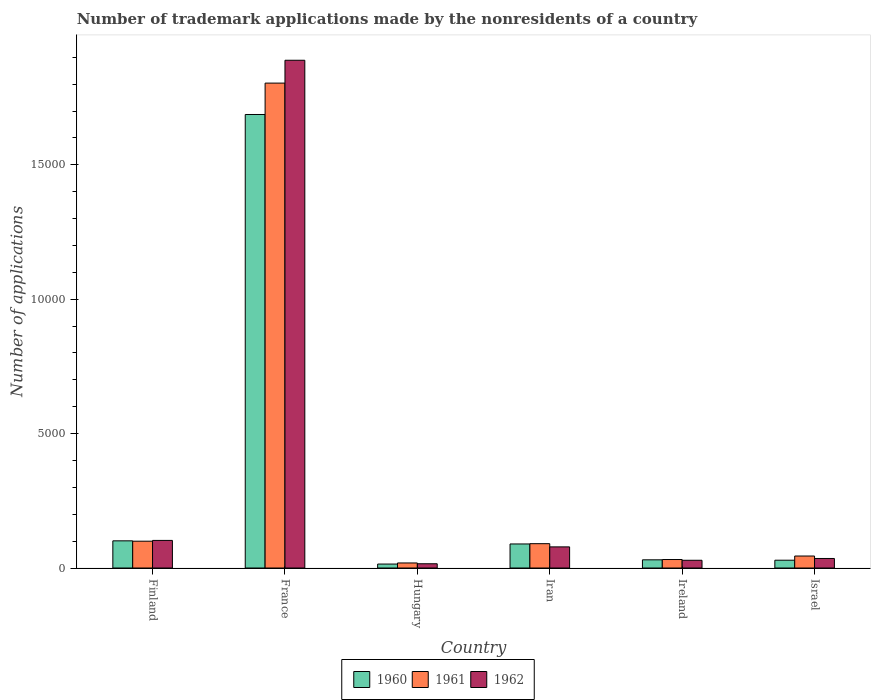How many different coloured bars are there?
Your answer should be very brief. 3. How many groups of bars are there?
Make the answer very short. 6. Are the number of bars per tick equal to the number of legend labels?
Your response must be concise. Yes. How many bars are there on the 4th tick from the left?
Give a very brief answer. 3. What is the number of trademark applications made by the nonresidents in 1961 in Ireland?
Your answer should be compact. 316. Across all countries, what is the maximum number of trademark applications made by the nonresidents in 1960?
Ensure brevity in your answer.  1.69e+04. Across all countries, what is the minimum number of trademark applications made by the nonresidents in 1962?
Offer a very short reply. 158. In which country was the number of trademark applications made by the nonresidents in 1962 minimum?
Your answer should be compact. Hungary. What is the total number of trademark applications made by the nonresidents in 1961 in the graph?
Ensure brevity in your answer.  2.09e+04. What is the difference between the number of trademark applications made by the nonresidents in 1961 in France and that in Iran?
Offer a terse response. 1.71e+04. What is the difference between the number of trademark applications made by the nonresidents in 1962 in Ireland and the number of trademark applications made by the nonresidents in 1960 in Iran?
Give a very brief answer. -607. What is the average number of trademark applications made by the nonresidents in 1960 per country?
Your answer should be compact. 3253.67. In how many countries, is the number of trademark applications made by the nonresidents in 1961 greater than 2000?
Provide a short and direct response. 1. What is the ratio of the number of trademark applications made by the nonresidents in 1961 in Iran to that in Israel?
Offer a very short reply. 2.03. Is the number of trademark applications made by the nonresidents in 1962 in Finland less than that in Iran?
Offer a terse response. No. What is the difference between the highest and the second highest number of trademark applications made by the nonresidents in 1960?
Your answer should be very brief. 1.59e+04. What is the difference between the highest and the lowest number of trademark applications made by the nonresidents in 1962?
Provide a short and direct response. 1.87e+04. What does the 3rd bar from the left in Finland represents?
Your response must be concise. 1962. What does the 3rd bar from the right in Finland represents?
Offer a very short reply. 1960. Are all the bars in the graph horizontal?
Provide a short and direct response. No. How many countries are there in the graph?
Your answer should be compact. 6. Does the graph contain any zero values?
Provide a short and direct response. No. Does the graph contain grids?
Provide a succinct answer. No. Where does the legend appear in the graph?
Your answer should be very brief. Bottom center. How many legend labels are there?
Provide a succinct answer. 3. How are the legend labels stacked?
Your response must be concise. Horizontal. What is the title of the graph?
Keep it short and to the point. Number of trademark applications made by the nonresidents of a country. Does "1969" appear as one of the legend labels in the graph?
Ensure brevity in your answer.  No. What is the label or title of the X-axis?
Provide a succinct answer. Country. What is the label or title of the Y-axis?
Ensure brevity in your answer.  Number of applications. What is the Number of applications of 1960 in Finland?
Give a very brief answer. 1011. What is the Number of applications of 1961 in Finland?
Provide a short and direct response. 998. What is the Number of applications of 1962 in Finland?
Offer a very short reply. 1027. What is the Number of applications in 1960 in France?
Your answer should be compact. 1.69e+04. What is the Number of applications of 1961 in France?
Provide a succinct answer. 1.80e+04. What is the Number of applications in 1962 in France?
Keep it short and to the point. 1.89e+04. What is the Number of applications in 1960 in Hungary?
Offer a very short reply. 147. What is the Number of applications of 1961 in Hungary?
Your answer should be very brief. 188. What is the Number of applications in 1962 in Hungary?
Offer a terse response. 158. What is the Number of applications of 1960 in Iran?
Give a very brief answer. 895. What is the Number of applications of 1961 in Iran?
Make the answer very short. 905. What is the Number of applications in 1962 in Iran?
Provide a succinct answer. 786. What is the Number of applications in 1960 in Ireland?
Your answer should be very brief. 305. What is the Number of applications in 1961 in Ireland?
Your answer should be very brief. 316. What is the Number of applications in 1962 in Ireland?
Offer a terse response. 288. What is the Number of applications in 1960 in Israel?
Make the answer very short. 290. What is the Number of applications in 1961 in Israel?
Provide a short and direct response. 446. What is the Number of applications of 1962 in Israel?
Give a very brief answer. 355. Across all countries, what is the maximum Number of applications of 1960?
Your answer should be compact. 1.69e+04. Across all countries, what is the maximum Number of applications of 1961?
Your answer should be compact. 1.80e+04. Across all countries, what is the maximum Number of applications of 1962?
Give a very brief answer. 1.89e+04. Across all countries, what is the minimum Number of applications of 1960?
Ensure brevity in your answer.  147. Across all countries, what is the minimum Number of applications in 1961?
Your response must be concise. 188. Across all countries, what is the minimum Number of applications in 1962?
Provide a succinct answer. 158. What is the total Number of applications in 1960 in the graph?
Make the answer very short. 1.95e+04. What is the total Number of applications of 1961 in the graph?
Provide a short and direct response. 2.09e+04. What is the total Number of applications of 1962 in the graph?
Ensure brevity in your answer.  2.15e+04. What is the difference between the Number of applications of 1960 in Finland and that in France?
Ensure brevity in your answer.  -1.59e+04. What is the difference between the Number of applications of 1961 in Finland and that in France?
Give a very brief answer. -1.70e+04. What is the difference between the Number of applications in 1962 in Finland and that in France?
Make the answer very short. -1.79e+04. What is the difference between the Number of applications in 1960 in Finland and that in Hungary?
Your answer should be compact. 864. What is the difference between the Number of applications of 1961 in Finland and that in Hungary?
Give a very brief answer. 810. What is the difference between the Number of applications of 1962 in Finland and that in Hungary?
Keep it short and to the point. 869. What is the difference between the Number of applications of 1960 in Finland and that in Iran?
Keep it short and to the point. 116. What is the difference between the Number of applications of 1961 in Finland and that in Iran?
Provide a short and direct response. 93. What is the difference between the Number of applications of 1962 in Finland and that in Iran?
Provide a succinct answer. 241. What is the difference between the Number of applications of 1960 in Finland and that in Ireland?
Give a very brief answer. 706. What is the difference between the Number of applications in 1961 in Finland and that in Ireland?
Keep it short and to the point. 682. What is the difference between the Number of applications in 1962 in Finland and that in Ireland?
Provide a short and direct response. 739. What is the difference between the Number of applications of 1960 in Finland and that in Israel?
Your answer should be compact. 721. What is the difference between the Number of applications of 1961 in Finland and that in Israel?
Provide a short and direct response. 552. What is the difference between the Number of applications in 1962 in Finland and that in Israel?
Give a very brief answer. 672. What is the difference between the Number of applications in 1960 in France and that in Hungary?
Your answer should be very brief. 1.67e+04. What is the difference between the Number of applications in 1961 in France and that in Hungary?
Your response must be concise. 1.79e+04. What is the difference between the Number of applications in 1962 in France and that in Hungary?
Make the answer very short. 1.87e+04. What is the difference between the Number of applications of 1960 in France and that in Iran?
Offer a terse response. 1.60e+04. What is the difference between the Number of applications in 1961 in France and that in Iran?
Give a very brief answer. 1.71e+04. What is the difference between the Number of applications in 1962 in France and that in Iran?
Give a very brief answer. 1.81e+04. What is the difference between the Number of applications in 1960 in France and that in Ireland?
Your answer should be compact. 1.66e+04. What is the difference between the Number of applications in 1961 in France and that in Ireland?
Ensure brevity in your answer.  1.77e+04. What is the difference between the Number of applications in 1962 in France and that in Ireland?
Your answer should be compact. 1.86e+04. What is the difference between the Number of applications in 1960 in France and that in Israel?
Offer a very short reply. 1.66e+04. What is the difference between the Number of applications in 1961 in France and that in Israel?
Your answer should be compact. 1.76e+04. What is the difference between the Number of applications of 1962 in France and that in Israel?
Give a very brief answer. 1.85e+04. What is the difference between the Number of applications in 1960 in Hungary and that in Iran?
Provide a succinct answer. -748. What is the difference between the Number of applications of 1961 in Hungary and that in Iran?
Your response must be concise. -717. What is the difference between the Number of applications in 1962 in Hungary and that in Iran?
Offer a terse response. -628. What is the difference between the Number of applications of 1960 in Hungary and that in Ireland?
Your answer should be compact. -158. What is the difference between the Number of applications in 1961 in Hungary and that in Ireland?
Make the answer very short. -128. What is the difference between the Number of applications in 1962 in Hungary and that in Ireland?
Provide a succinct answer. -130. What is the difference between the Number of applications of 1960 in Hungary and that in Israel?
Your answer should be very brief. -143. What is the difference between the Number of applications in 1961 in Hungary and that in Israel?
Make the answer very short. -258. What is the difference between the Number of applications in 1962 in Hungary and that in Israel?
Provide a succinct answer. -197. What is the difference between the Number of applications of 1960 in Iran and that in Ireland?
Give a very brief answer. 590. What is the difference between the Number of applications in 1961 in Iran and that in Ireland?
Offer a very short reply. 589. What is the difference between the Number of applications in 1962 in Iran and that in Ireland?
Provide a succinct answer. 498. What is the difference between the Number of applications in 1960 in Iran and that in Israel?
Make the answer very short. 605. What is the difference between the Number of applications in 1961 in Iran and that in Israel?
Ensure brevity in your answer.  459. What is the difference between the Number of applications of 1962 in Iran and that in Israel?
Make the answer very short. 431. What is the difference between the Number of applications of 1961 in Ireland and that in Israel?
Your answer should be very brief. -130. What is the difference between the Number of applications of 1962 in Ireland and that in Israel?
Ensure brevity in your answer.  -67. What is the difference between the Number of applications of 1960 in Finland and the Number of applications of 1961 in France?
Your answer should be very brief. -1.70e+04. What is the difference between the Number of applications of 1960 in Finland and the Number of applications of 1962 in France?
Provide a succinct answer. -1.79e+04. What is the difference between the Number of applications of 1961 in Finland and the Number of applications of 1962 in France?
Make the answer very short. -1.79e+04. What is the difference between the Number of applications of 1960 in Finland and the Number of applications of 1961 in Hungary?
Your response must be concise. 823. What is the difference between the Number of applications in 1960 in Finland and the Number of applications in 1962 in Hungary?
Keep it short and to the point. 853. What is the difference between the Number of applications of 1961 in Finland and the Number of applications of 1962 in Hungary?
Provide a short and direct response. 840. What is the difference between the Number of applications of 1960 in Finland and the Number of applications of 1961 in Iran?
Your answer should be very brief. 106. What is the difference between the Number of applications of 1960 in Finland and the Number of applications of 1962 in Iran?
Your answer should be compact. 225. What is the difference between the Number of applications in 1961 in Finland and the Number of applications in 1962 in Iran?
Provide a succinct answer. 212. What is the difference between the Number of applications of 1960 in Finland and the Number of applications of 1961 in Ireland?
Your answer should be compact. 695. What is the difference between the Number of applications of 1960 in Finland and the Number of applications of 1962 in Ireland?
Offer a terse response. 723. What is the difference between the Number of applications of 1961 in Finland and the Number of applications of 1962 in Ireland?
Ensure brevity in your answer.  710. What is the difference between the Number of applications of 1960 in Finland and the Number of applications of 1961 in Israel?
Your response must be concise. 565. What is the difference between the Number of applications of 1960 in Finland and the Number of applications of 1962 in Israel?
Your response must be concise. 656. What is the difference between the Number of applications in 1961 in Finland and the Number of applications in 1962 in Israel?
Keep it short and to the point. 643. What is the difference between the Number of applications of 1960 in France and the Number of applications of 1961 in Hungary?
Keep it short and to the point. 1.67e+04. What is the difference between the Number of applications in 1960 in France and the Number of applications in 1962 in Hungary?
Provide a succinct answer. 1.67e+04. What is the difference between the Number of applications of 1961 in France and the Number of applications of 1962 in Hungary?
Your answer should be compact. 1.79e+04. What is the difference between the Number of applications in 1960 in France and the Number of applications in 1961 in Iran?
Ensure brevity in your answer.  1.60e+04. What is the difference between the Number of applications of 1960 in France and the Number of applications of 1962 in Iran?
Your response must be concise. 1.61e+04. What is the difference between the Number of applications in 1961 in France and the Number of applications in 1962 in Iran?
Your answer should be compact. 1.73e+04. What is the difference between the Number of applications in 1960 in France and the Number of applications in 1961 in Ireland?
Give a very brief answer. 1.66e+04. What is the difference between the Number of applications in 1960 in France and the Number of applications in 1962 in Ireland?
Keep it short and to the point. 1.66e+04. What is the difference between the Number of applications of 1961 in France and the Number of applications of 1962 in Ireland?
Ensure brevity in your answer.  1.78e+04. What is the difference between the Number of applications of 1960 in France and the Number of applications of 1961 in Israel?
Your answer should be very brief. 1.64e+04. What is the difference between the Number of applications of 1960 in France and the Number of applications of 1962 in Israel?
Your response must be concise. 1.65e+04. What is the difference between the Number of applications in 1961 in France and the Number of applications in 1962 in Israel?
Offer a terse response. 1.77e+04. What is the difference between the Number of applications of 1960 in Hungary and the Number of applications of 1961 in Iran?
Ensure brevity in your answer.  -758. What is the difference between the Number of applications in 1960 in Hungary and the Number of applications in 1962 in Iran?
Offer a terse response. -639. What is the difference between the Number of applications in 1961 in Hungary and the Number of applications in 1962 in Iran?
Ensure brevity in your answer.  -598. What is the difference between the Number of applications in 1960 in Hungary and the Number of applications in 1961 in Ireland?
Your answer should be compact. -169. What is the difference between the Number of applications of 1960 in Hungary and the Number of applications of 1962 in Ireland?
Offer a terse response. -141. What is the difference between the Number of applications in 1961 in Hungary and the Number of applications in 1962 in Ireland?
Provide a short and direct response. -100. What is the difference between the Number of applications of 1960 in Hungary and the Number of applications of 1961 in Israel?
Give a very brief answer. -299. What is the difference between the Number of applications in 1960 in Hungary and the Number of applications in 1962 in Israel?
Offer a terse response. -208. What is the difference between the Number of applications in 1961 in Hungary and the Number of applications in 1962 in Israel?
Provide a succinct answer. -167. What is the difference between the Number of applications of 1960 in Iran and the Number of applications of 1961 in Ireland?
Provide a short and direct response. 579. What is the difference between the Number of applications in 1960 in Iran and the Number of applications in 1962 in Ireland?
Your answer should be compact. 607. What is the difference between the Number of applications in 1961 in Iran and the Number of applications in 1962 in Ireland?
Your answer should be compact. 617. What is the difference between the Number of applications in 1960 in Iran and the Number of applications in 1961 in Israel?
Your answer should be very brief. 449. What is the difference between the Number of applications of 1960 in Iran and the Number of applications of 1962 in Israel?
Your answer should be compact. 540. What is the difference between the Number of applications in 1961 in Iran and the Number of applications in 1962 in Israel?
Provide a succinct answer. 550. What is the difference between the Number of applications of 1960 in Ireland and the Number of applications of 1961 in Israel?
Offer a terse response. -141. What is the difference between the Number of applications of 1961 in Ireland and the Number of applications of 1962 in Israel?
Give a very brief answer. -39. What is the average Number of applications of 1960 per country?
Offer a terse response. 3253.67. What is the average Number of applications in 1961 per country?
Provide a short and direct response. 3482.5. What is the average Number of applications of 1962 per country?
Keep it short and to the point. 3584.33. What is the difference between the Number of applications in 1960 and Number of applications in 1962 in Finland?
Provide a short and direct response. -16. What is the difference between the Number of applications of 1961 and Number of applications of 1962 in Finland?
Provide a short and direct response. -29. What is the difference between the Number of applications of 1960 and Number of applications of 1961 in France?
Your response must be concise. -1168. What is the difference between the Number of applications of 1960 and Number of applications of 1962 in France?
Provide a succinct answer. -2018. What is the difference between the Number of applications in 1961 and Number of applications in 1962 in France?
Provide a short and direct response. -850. What is the difference between the Number of applications of 1960 and Number of applications of 1961 in Hungary?
Your answer should be compact. -41. What is the difference between the Number of applications of 1960 and Number of applications of 1962 in Iran?
Provide a succinct answer. 109. What is the difference between the Number of applications of 1961 and Number of applications of 1962 in Iran?
Make the answer very short. 119. What is the difference between the Number of applications of 1960 and Number of applications of 1962 in Ireland?
Your answer should be very brief. 17. What is the difference between the Number of applications of 1960 and Number of applications of 1961 in Israel?
Offer a very short reply. -156. What is the difference between the Number of applications in 1960 and Number of applications in 1962 in Israel?
Your answer should be compact. -65. What is the difference between the Number of applications of 1961 and Number of applications of 1962 in Israel?
Make the answer very short. 91. What is the ratio of the Number of applications in 1960 in Finland to that in France?
Give a very brief answer. 0.06. What is the ratio of the Number of applications in 1961 in Finland to that in France?
Offer a very short reply. 0.06. What is the ratio of the Number of applications of 1962 in Finland to that in France?
Keep it short and to the point. 0.05. What is the ratio of the Number of applications of 1960 in Finland to that in Hungary?
Give a very brief answer. 6.88. What is the ratio of the Number of applications in 1961 in Finland to that in Hungary?
Your answer should be very brief. 5.31. What is the ratio of the Number of applications of 1960 in Finland to that in Iran?
Your answer should be very brief. 1.13. What is the ratio of the Number of applications in 1961 in Finland to that in Iran?
Offer a very short reply. 1.1. What is the ratio of the Number of applications in 1962 in Finland to that in Iran?
Give a very brief answer. 1.31. What is the ratio of the Number of applications of 1960 in Finland to that in Ireland?
Your response must be concise. 3.31. What is the ratio of the Number of applications of 1961 in Finland to that in Ireland?
Your answer should be very brief. 3.16. What is the ratio of the Number of applications of 1962 in Finland to that in Ireland?
Keep it short and to the point. 3.57. What is the ratio of the Number of applications of 1960 in Finland to that in Israel?
Keep it short and to the point. 3.49. What is the ratio of the Number of applications of 1961 in Finland to that in Israel?
Keep it short and to the point. 2.24. What is the ratio of the Number of applications of 1962 in Finland to that in Israel?
Ensure brevity in your answer.  2.89. What is the ratio of the Number of applications in 1960 in France to that in Hungary?
Offer a very short reply. 114.79. What is the ratio of the Number of applications of 1961 in France to that in Hungary?
Offer a terse response. 95.97. What is the ratio of the Number of applications in 1962 in France to that in Hungary?
Your answer should be compact. 119.57. What is the ratio of the Number of applications of 1960 in France to that in Iran?
Provide a succinct answer. 18.85. What is the ratio of the Number of applications in 1961 in France to that in Iran?
Your answer should be very brief. 19.94. What is the ratio of the Number of applications in 1962 in France to that in Iran?
Ensure brevity in your answer.  24.04. What is the ratio of the Number of applications of 1960 in France to that in Ireland?
Ensure brevity in your answer.  55.32. What is the ratio of the Number of applications in 1961 in France to that in Ireland?
Keep it short and to the point. 57.09. What is the ratio of the Number of applications of 1962 in France to that in Ireland?
Your answer should be very brief. 65.6. What is the ratio of the Number of applications in 1960 in France to that in Israel?
Ensure brevity in your answer.  58.19. What is the ratio of the Number of applications in 1961 in France to that in Israel?
Make the answer very short. 40.45. What is the ratio of the Number of applications in 1962 in France to that in Israel?
Offer a very short reply. 53.22. What is the ratio of the Number of applications in 1960 in Hungary to that in Iran?
Give a very brief answer. 0.16. What is the ratio of the Number of applications of 1961 in Hungary to that in Iran?
Provide a short and direct response. 0.21. What is the ratio of the Number of applications of 1962 in Hungary to that in Iran?
Provide a short and direct response. 0.2. What is the ratio of the Number of applications of 1960 in Hungary to that in Ireland?
Make the answer very short. 0.48. What is the ratio of the Number of applications of 1961 in Hungary to that in Ireland?
Provide a short and direct response. 0.59. What is the ratio of the Number of applications of 1962 in Hungary to that in Ireland?
Your answer should be very brief. 0.55. What is the ratio of the Number of applications in 1960 in Hungary to that in Israel?
Your answer should be compact. 0.51. What is the ratio of the Number of applications of 1961 in Hungary to that in Israel?
Keep it short and to the point. 0.42. What is the ratio of the Number of applications in 1962 in Hungary to that in Israel?
Provide a short and direct response. 0.45. What is the ratio of the Number of applications of 1960 in Iran to that in Ireland?
Your answer should be very brief. 2.93. What is the ratio of the Number of applications of 1961 in Iran to that in Ireland?
Your response must be concise. 2.86. What is the ratio of the Number of applications of 1962 in Iran to that in Ireland?
Keep it short and to the point. 2.73. What is the ratio of the Number of applications of 1960 in Iran to that in Israel?
Your answer should be compact. 3.09. What is the ratio of the Number of applications in 1961 in Iran to that in Israel?
Your answer should be very brief. 2.03. What is the ratio of the Number of applications in 1962 in Iran to that in Israel?
Your answer should be very brief. 2.21. What is the ratio of the Number of applications in 1960 in Ireland to that in Israel?
Keep it short and to the point. 1.05. What is the ratio of the Number of applications of 1961 in Ireland to that in Israel?
Offer a terse response. 0.71. What is the ratio of the Number of applications in 1962 in Ireland to that in Israel?
Keep it short and to the point. 0.81. What is the difference between the highest and the second highest Number of applications in 1960?
Provide a short and direct response. 1.59e+04. What is the difference between the highest and the second highest Number of applications in 1961?
Your response must be concise. 1.70e+04. What is the difference between the highest and the second highest Number of applications in 1962?
Provide a short and direct response. 1.79e+04. What is the difference between the highest and the lowest Number of applications in 1960?
Provide a short and direct response. 1.67e+04. What is the difference between the highest and the lowest Number of applications of 1961?
Offer a very short reply. 1.79e+04. What is the difference between the highest and the lowest Number of applications in 1962?
Ensure brevity in your answer.  1.87e+04. 